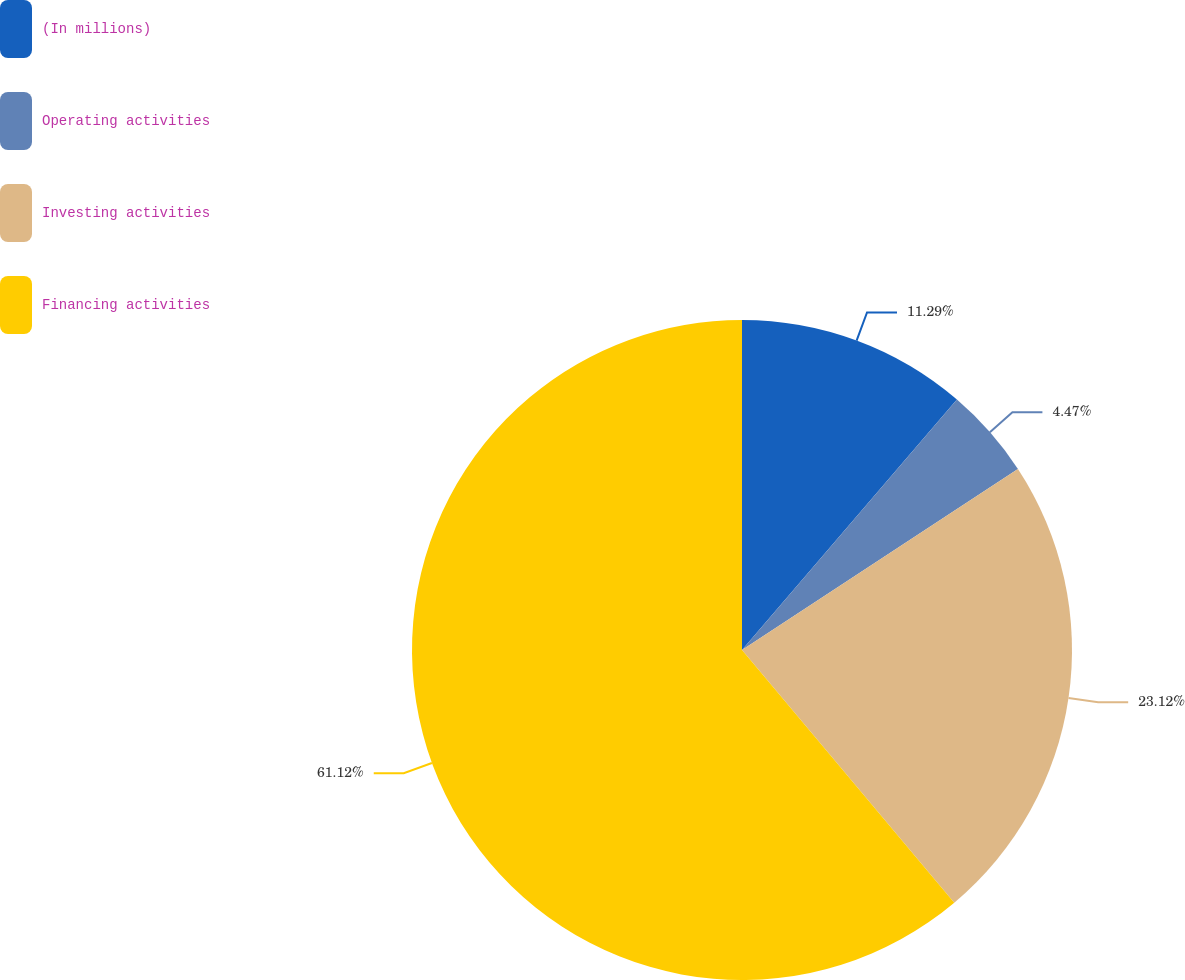<chart> <loc_0><loc_0><loc_500><loc_500><pie_chart><fcel>(In millions)<fcel>Operating activities<fcel>Investing activities<fcel>Financing activities<nl><fcel>11.29%<fcel>4.47%<fcel>23.12%<fcel>61.12%<nl></chart> 